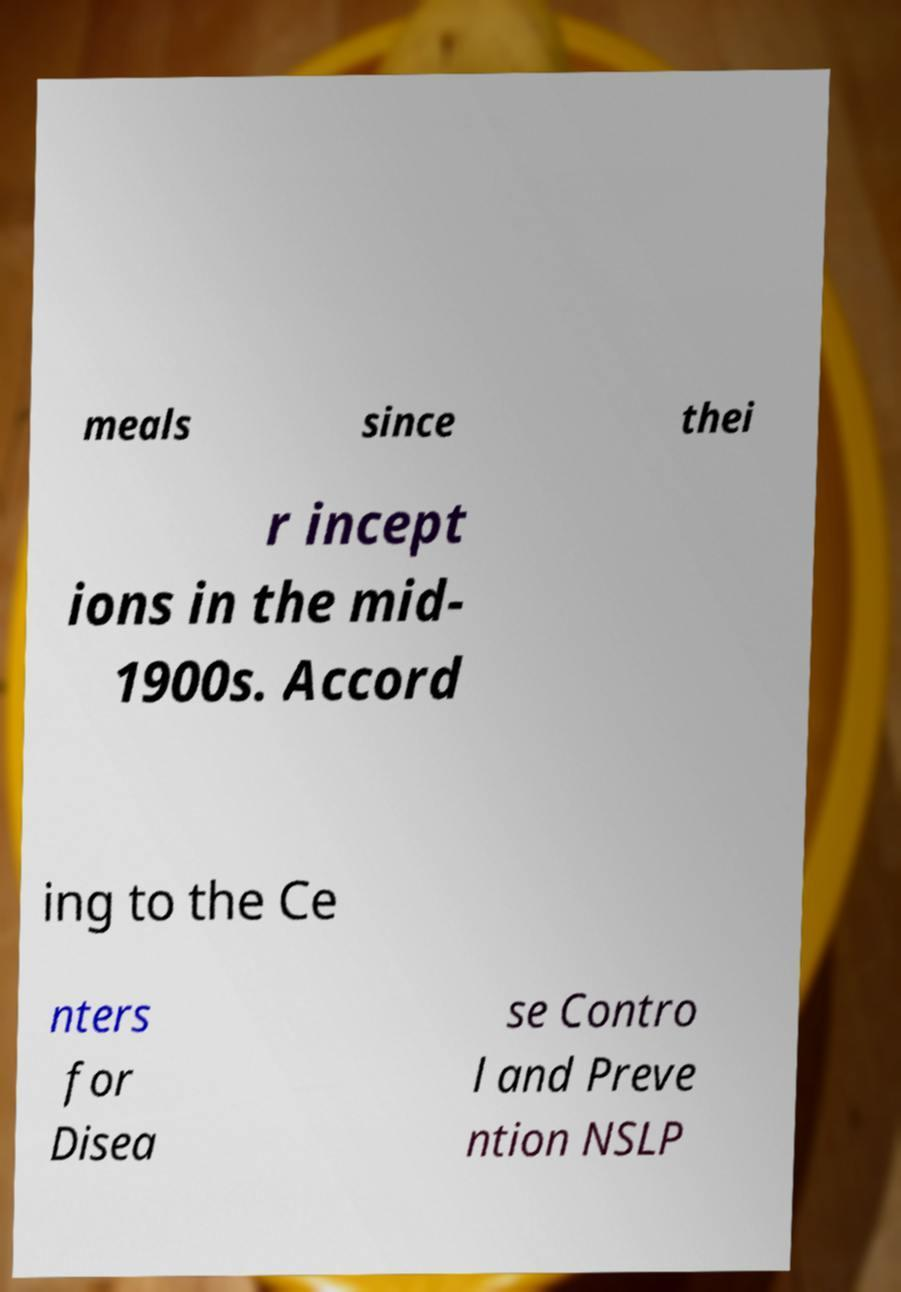Can you accurately transcribe the text from the provided image for me? meals since thei r incept ions in the mid- 1900s. Accord ing to the Ce nters for Disea se Contro l and Preve ntion NSLP 